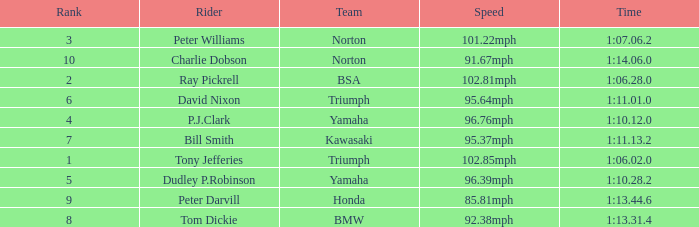How many Ranks have ray pickrell as a Rider? 1.0. Could you help me parse every detail presented in this table? {'header': ['Rank', 'Rider', 'Team', 'Speed', 'Time'], 'rows': [['3', 'Peter Williams', 'Norton', '101.22mph', '1:07.06.2'], ['10', 'Charlie Dobson', 'Norton', '91.67mph', '1:14.06.0'], ['2', 'Ray Pickrell', 'BSA', '102.81mph', '1:06.28.0'], ['6', 'David Nixon', 'Triumph', '95.64mph', '1:11.01.0'], ['4', 'P.J.Clark', 'Yamaha', '96.76mph', '1:10.12.0'], ['7', 'Bill Smith', 'Kawasaki', '95.37mph', '1:11.13.2'], ['1', 'Tony Jefferies', 'Triumph', '102.85mph', '1:06.02.0'], ['5', 'Dudley P.Robinson', 'Yamaha', '96.39mph', '1:10.28.2'], ['9', 'Peter Darvill', 'Honda', '85.81mph', '1:13.44.6'], ['8', 'Tom Dickie', 'BMW', '92.38mph', '1:13.31.4']]} 